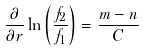Convert formula to latex. <formula><loc_0><loc_0><loc_500><loc_500>\frac { \partial } { \partial r } \ln \left ( \frac { f _ { 2 } } { f _ { 1 } } \right ) = \frac { m - n } { C }</formula> 